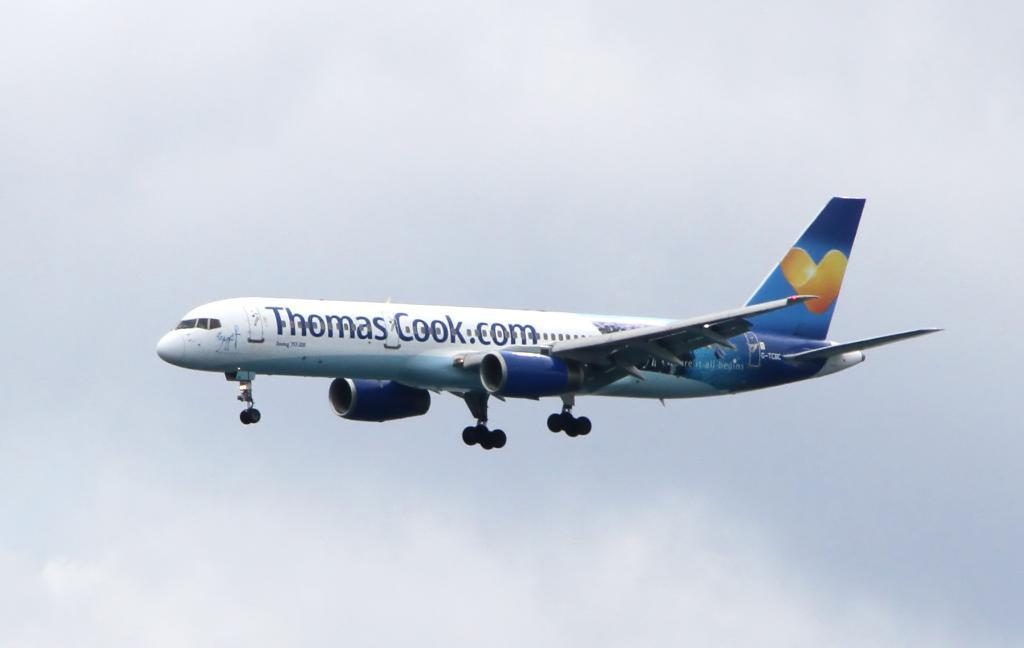<image>
Create a compact narrative representing the image presented. The plane advertises Thomas Cook.com along the side of it. 